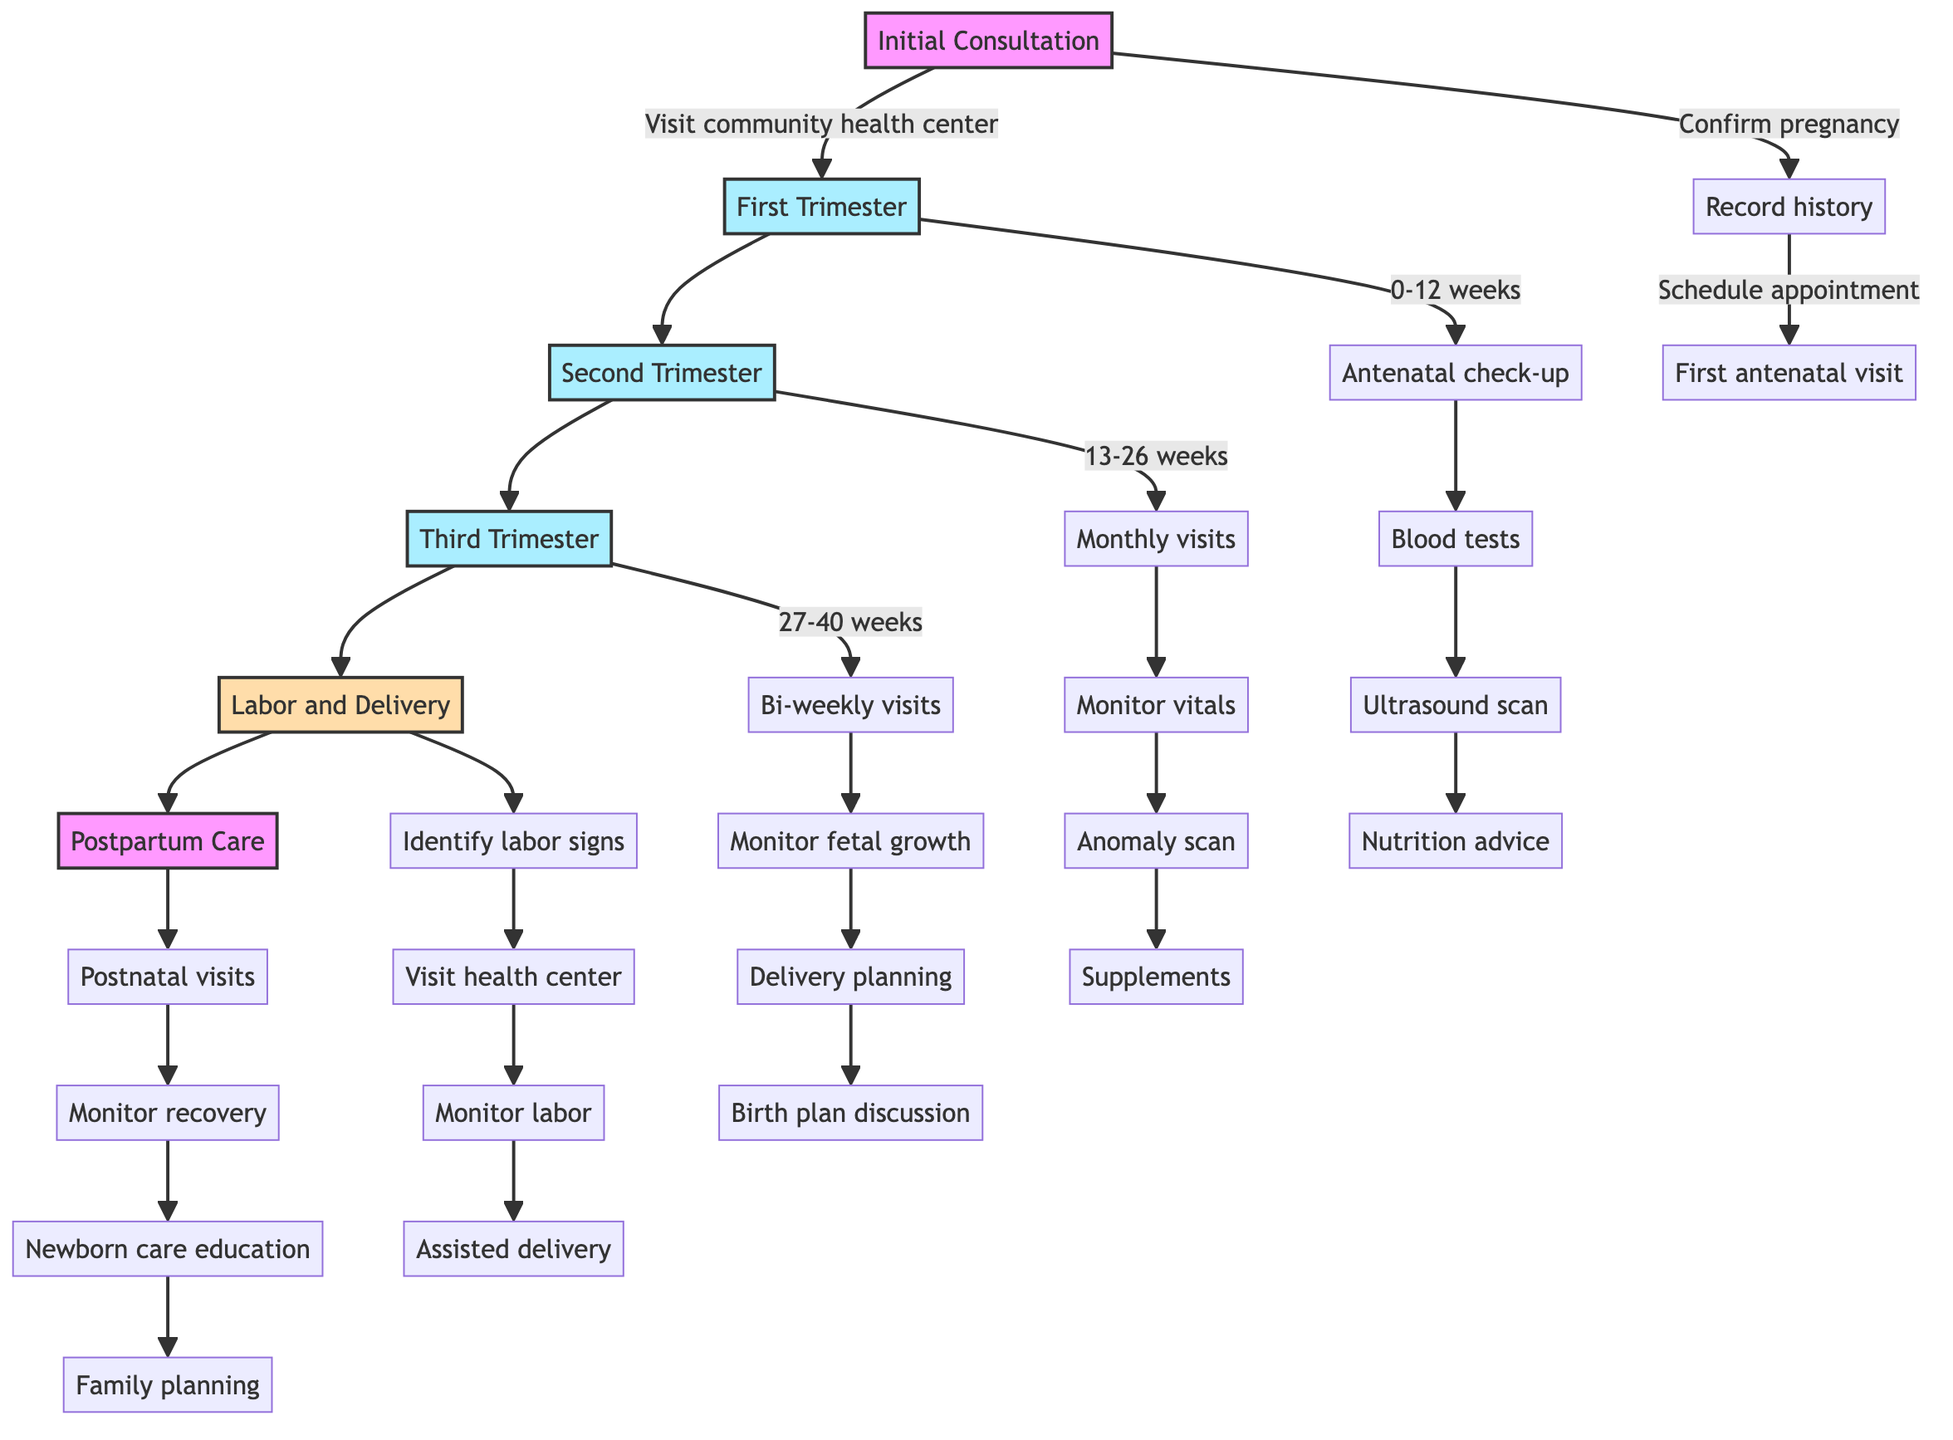What is the first step in the pregnancy pathway? The first step in the pathway is "Initial Consultation" as indicated in the diagram.
Answer: Initial Consultation How many trimesters are there in the pathway? The pathway includes three trimesters: First, Second, and Third, which are outlined in the diagram.
Answer: Three What is conducted during the Second Trimester? In the Second Trimester, "Monthly antenatal visits" are conducted as shown in the diagram.
Answer: Monthly antenatal visits What happens before delivery in the Third Trimester? Before delivery, there are "Bi-weekly visits" and "Monitor fetal growth" in the Third Trimester according to the diagram.
Answer: Bi-weekly visits Which step includes labor signs identification? The step that includes labor signs identification is "Labor and Delivery," as depicted in the diagram.
Answer: Labor and Delivery What type of care is provided in the Postpartum Care? The Postpartum Care provides "Recovery and newborn care," which is specified in the description of the step.
Answer: Recovery and newborn care How often are antenatal visits recommended in the Third Trimester? In the Third Trimester, it is recommended to have "Bi-weekly antenatal visits" according to the pathway.
Answer: Bi-weekly antenatal visits What are the actions performed during the First Trimester? The First Trimester includes actions such as "First antenatal check-up," "Blood tests," and "Discuss nutrition," based on the elements in the diagram.
Answer: First antenatal check-up, Blood tests, Discuss nutrition What step follows the Second Trimester? The step that follows the Second Trimester is "Third Trimester," as shown in the flowchart.
Answer: Third Trimester 